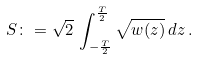Convert formula to latex. <formula><loc_0><loc_0><loc_500><loc_500>S \colon = \sqrt { 2 } \, \int _ { - \frac { T } { 2 } } ^ { \frac { T } { 2 } } \sqrt { { w } ( z ) } \, d z \, .</formula> 